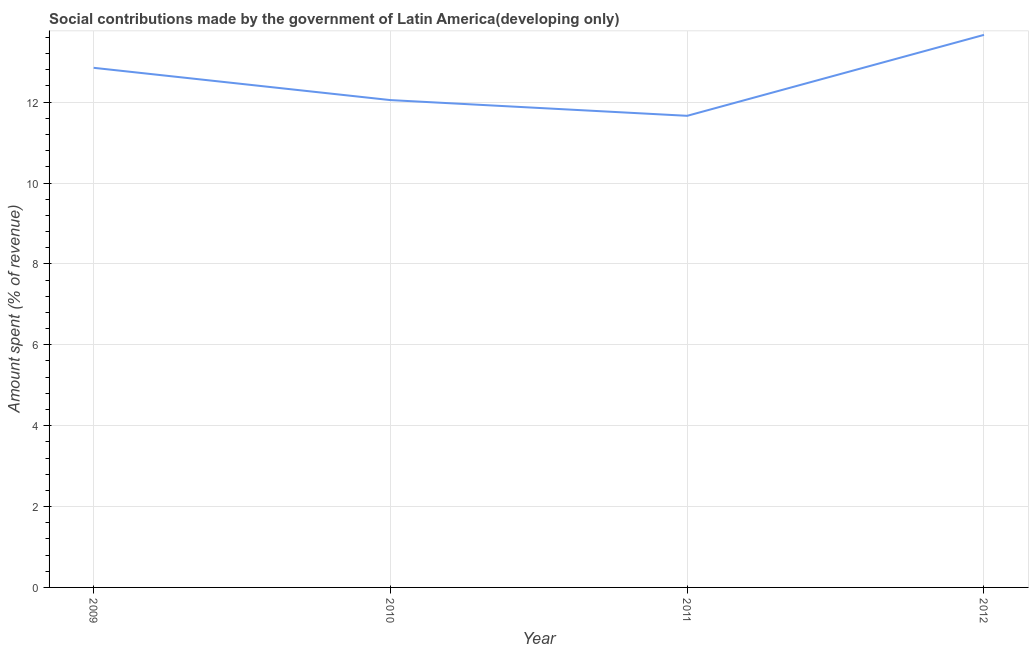What is the amount spent in making social contributions in 2012?
Your answer should be compact. 13.66. Across all years, what is the maximum amount spent in making social contributions?
Offer a very short reply. 13.66. Across all years, what is the minimum amount spent in making social contributions?
Provide a short and direct response. 11.66. In which year was the amount spent in making social contributions maximum?
Your answer should be compact. 2012. In which year was the amount spent in making social contributions minimum?
Your response must be concise. 2011. What is the sum of the amount spent in making social contributions?
Provide a short and direct response. 50.22. What is the difference between the amount spent in making social contributions in 2010 and 2011?
Keep it short and to the point. 0.39. What is the average amount spent in making social contributions per year?
Your answer should be very brief. 12.56. What is the median amount spent in making social contributions?
Your answer should be compact. 12.45. What is the ratio of the amount spent in making social contributions in 2010 to that in 2012?
Ensure brevity in your answer.  0.88. Is the difference between the amount spent in making social contributions in 2010 and 2011 greater than the difference between any two years?
Keep it short and to the point. No. What is the difference between the highest and the second highest amount spent in making social contributions?
Your answer should be compact. 0.81. What is the difference between the highest and the lowest amount spent in making social contributions?
Offer a terse response. 2. In how many years, is the amount spent in making social contributions greater than the average amount spent in making social contributions taken over all years?
Make the answer very short. 2. Does the amount spent in making social contributions monotonically increase over the years?
Your answer should be compact. No. How many lines are there?
Your answer should be compact. 1. Are the values on the major ticks of Y-axis written in scientific E-notation?
Ensure brevity in your answer.  No. Does the graph contain any zero values?
Make the answer very short. No. What is the title of the graph?
Your response must be concise. Social contributions made by the government of Latin America(developing only). What is the label or title of the X-axis?
Provide a succinct answer. Year. What is the label or title of the Y-axis?
Your response must be concise. Amount spent (% of revenue). What is the Amount spent (% of revenue) of 2009?
Offer a terse response. 12.85. What is the Amount spent (% of revenue) of 2010?
Make the answer very short. 12.05. What is the Amount spent (% of revenue) in 2011?
Give a very brief answer. 11.66. What is the Amount spent (% of revenue) of 2012?
Your answer should be compact. 13.66. What is the difference between the Amount spent (% of revenue) in 2009 and 2010?
Your answer should be very brief. 0.8. What is the difference between the Amount spent (% of revenue) in 2009 and 2011?
Your answer should be compact. 1.19. What is the difference between the Amount spent (% of revenue) in 2009 and 2012?
Give a very brief answer. -0.81. What is the difference between the Amount spent (% of revenue) in 2010 and 2011?
Your answer should be very brief. 0.39. What is the difference between the Amount spent (% of revenue) in 2010 and 2012?
Make the answer very short. -1.61. What is the difference between the Amount spent (% of revenue) in 2011 and 2012?
Your answer should be compact. -2. What is the ratio of the Amount spent (% of revenue) in 2009 to that in 2010?
Give a very brief answer. 1.07. What is the ratio of the Amount spent (% of revenue) in 2009 to that in 2011?
Provide a succinct answer. 1.1. What is the ratio of the Amount spent (% of revenue) in 2009 to that in 2012?
Your response must be concise. 0.94. What is the ratio of the Amount spent (% of revenue) in 2010 to that in 2011?
Provide a succinct answer. 1.03. What is the ratio of the Amount spent (% of revenue) in 2010 to that in 2012?
Give a very brief answer. 0.88. What is the ratio of the Amount spent (% of revenue) in 2011 to that in 2012?
Make the answer very short. 0.85. 